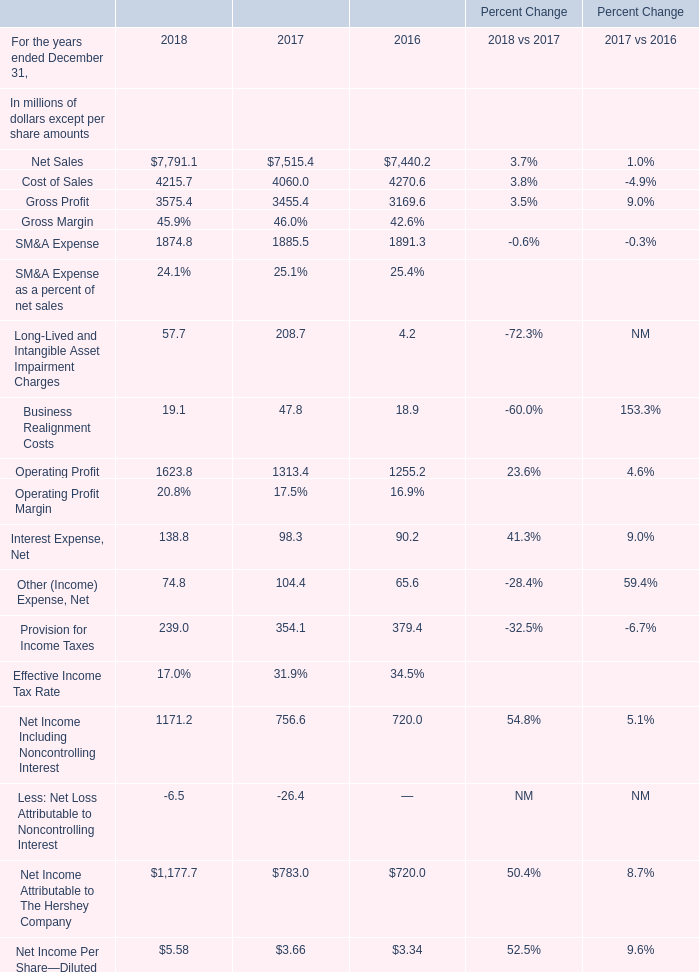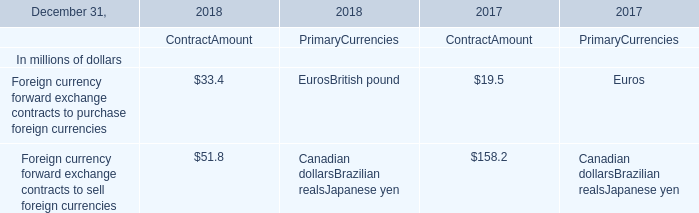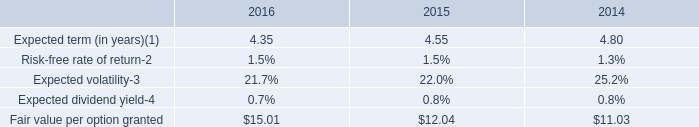If Cost of Sales develops with the same increasing rate in 2018, what will it reach in 2019? (in million) 
Computations: (4215.7 * (1 + ((4215.7 - 4060.0) / 4060)))
Answer: 4377.37106. 